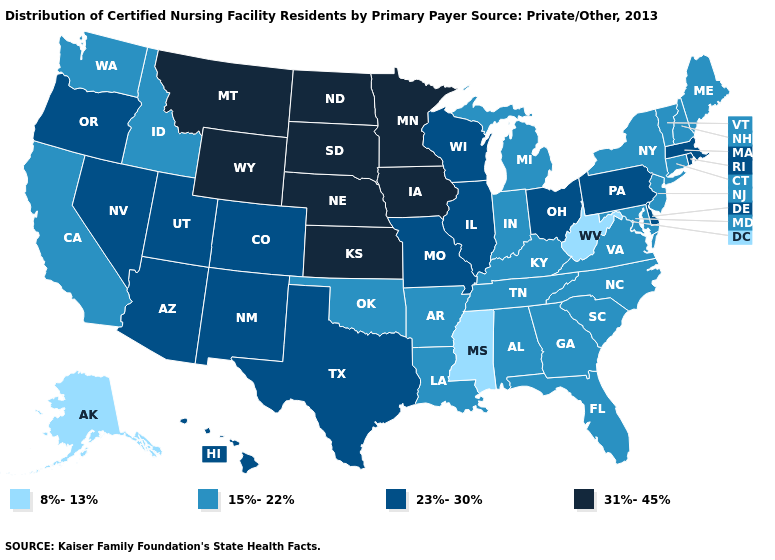Does the map have missing data?
Short answer required. No. Which states have the lowest value in the USA?
Concise answer only. Alaska, Mississippi, West Virginia. Does Florida have a lower value than Maryland?
Quick response, please. No. Name the states that have a value in the range 8%-13%?
Give a very brief answer. Alaska, Mississippi, West Virginia. Does New Hampshire have the highest value in the USA?
Give a very brief answer. No. What is the highest value in states that border Arkansas?
Quick response, please. 23%-30%. What is the highest value in the South ?
Concise answer only. 23%-30%. What is the value of Illinois?
Be succinct. 23%-30%. What is the value of West Virginia?
Keep it brief. 8%-13%. What is the value of Texas?
Answer briefly. 23%-30%. Does Montana have the highest value in the USA?
Write a very short answer. Yes. What is the value of Tennessee?
Write a very short answer. 15%-22%. What is the value of Maine?
Short answer required. 15%-22%. What is the value of Vermont?
Give a very brief answer. 15%-22%. What is the value of Georgia?
Give a very brief answer. 15%-22%. 